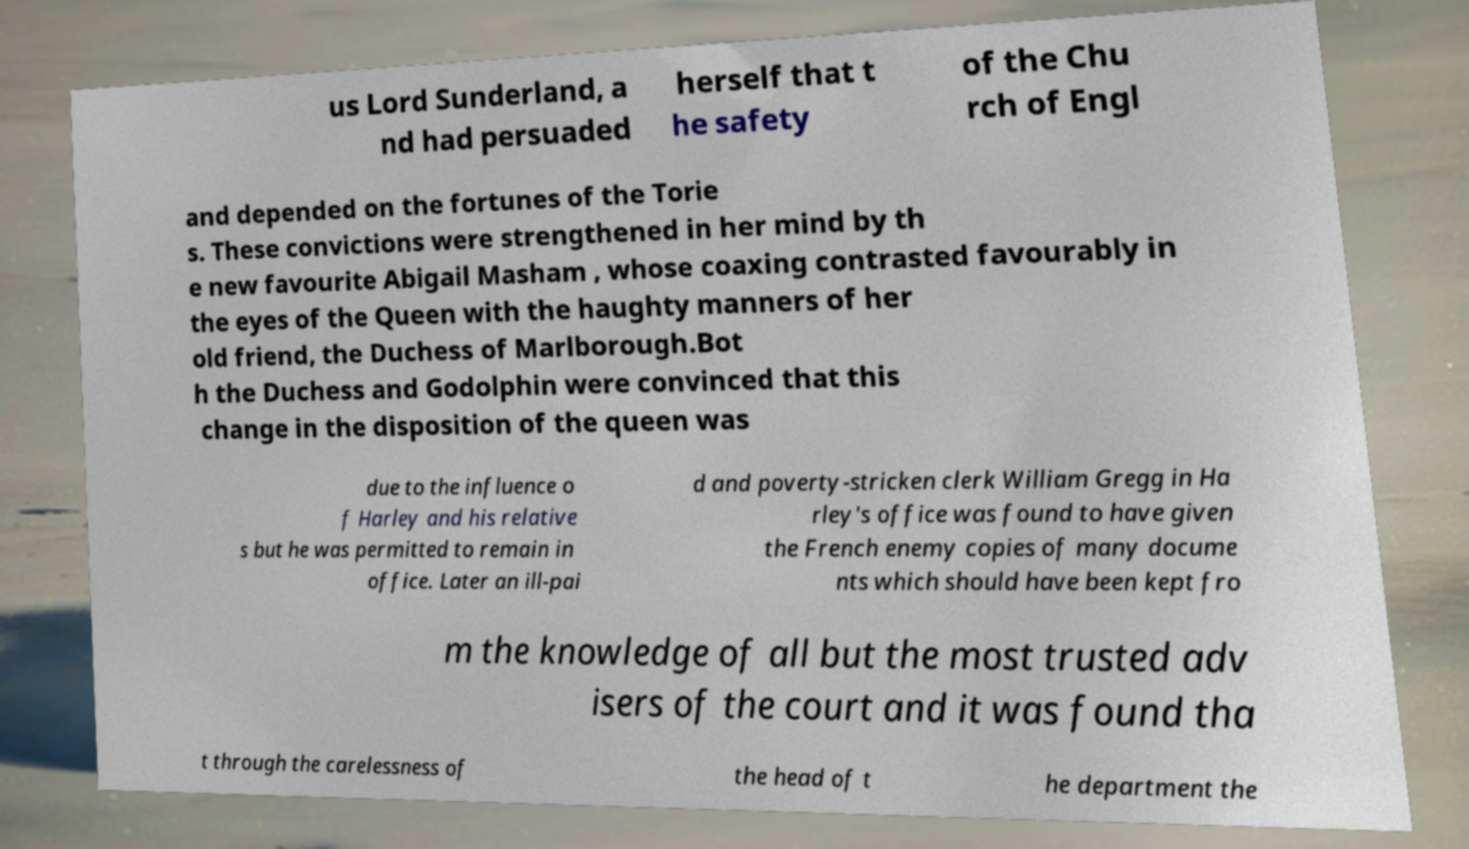Could you extract and type out the text from this image? us Lord Sunderland, a nd had persuaded herself that t he safety of the Chu rch of Engl and depended on the fortunes of the Torie s. These convictions were strengthened in her mind by th e new favourite Abigail Masham , whose coaxing contrasted favourably in the eyes of the Queen with the haughty manners of her old friend, the Duchess of Marlborough.Bot h the Duchess and Godolphin were convinced that this change in the disposition of the queen was due to the influence o f Harley and his relative s but he was permitted to remain in office. Later an ill-pai d and poverty-stricken clerk William Gregg in Ha rley's office was found to have given the French enemy copies of many docume nts which should have been kept fro m the knowledge of all but the most trusted adv isers of the court and it was found tha t through the carelessness of the head of t he department the 